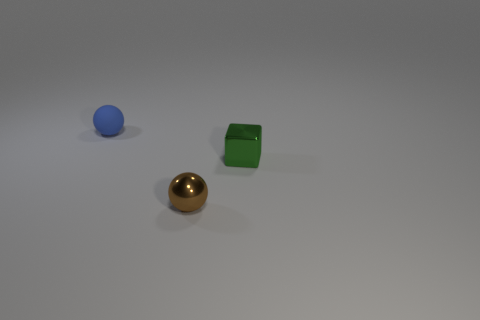Is there any other thing that has the same material as the blue object?
Offer a very short reply. No. What number of rubber objects are either tiny brown spheres or tiny purple spheres?
Keep it short and to the point. 0. What number of matte things are in front of the object right of the ball in front of the small blue matte object?
Your answer should be compact. 0. Does the ball that is behind the tiny green shiny cube have the same size as the metal object that is on the right side of the brown metallic sphere?
Your answer should be very brief. Yes. What is the material of the small blue object that is the same shape as the tiny brown metallic object?
Offer a very short reply. Rubber. How many large things are balls or green metal blocks?
Your answer should be compact. 0. What is the brown ball made of?
Give a very brief answer. Metal. What is the small object that is both to the left of the green metallic object and behind the small brown shiny thing made of?
Your answer should be very brief. Rubber. Do the rubber ball and the tiny ball that is in front of the green metallic object have the same color?
Make the answer very short. No. There is a blue object that is the same size as the brown metal ball; what is its material?
Make the answer very short. Rubber. 